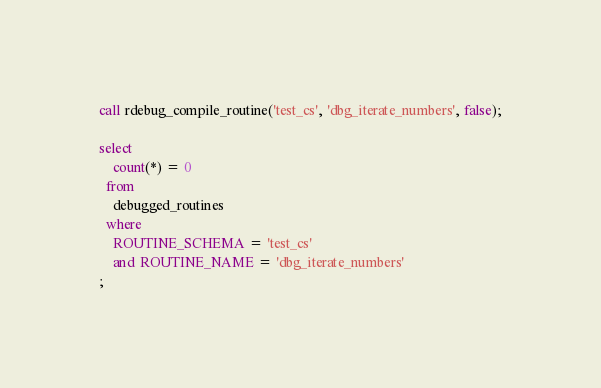<code> <loc_0><loc_0><loc_500><loc_500><_SQL_>call rdebug_compile_routine('test_cs', 'dbg_iterate_numbers', false);

select
    count(*) = 0
  from
    debugged_routines
  where 
    ROUTINE_SCHEMA = 'test_cs'
    and ROUTINE_NAME = 'dbg_iterate_numbers'
;</code> 